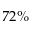Convert formula to latex. <formula><loc_0><loc_0><loc_500><loc_500>7 2 \%</formula> 